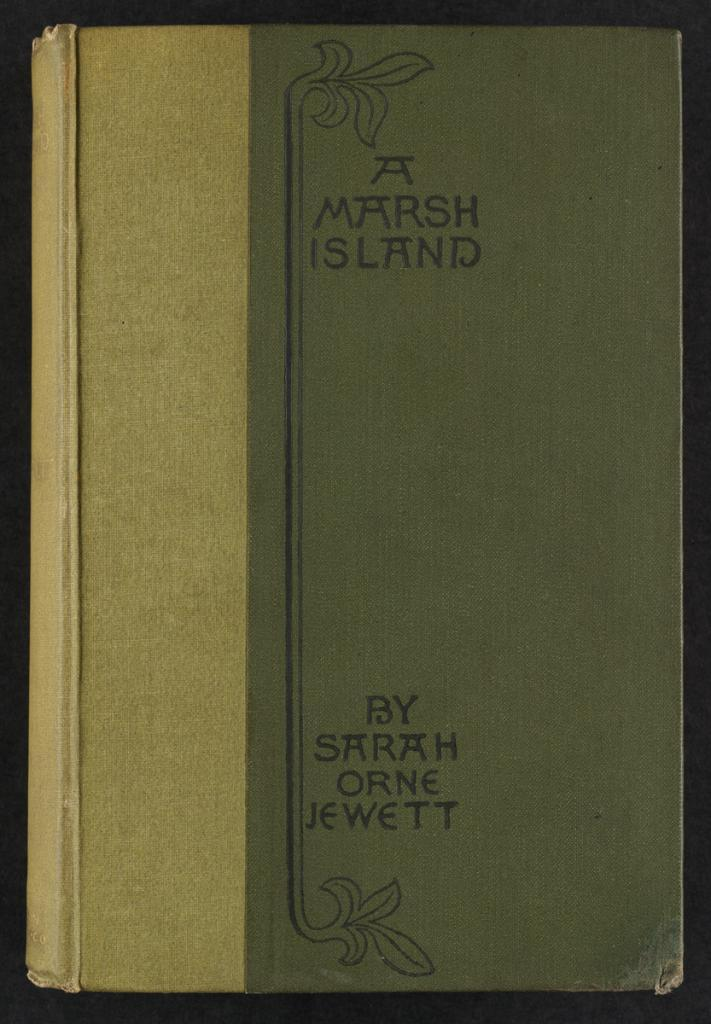What object is present in the image? There is a book in the image. What color is the book? The book is green in color. Is there any text or writing on the book? Yes, there is writing on the book. What can be seen in the background of the image? The background of the image is black. How does the book express anger in the image? The book does not express anger in the image, as it is an inanimate object and cannot display emotions. 